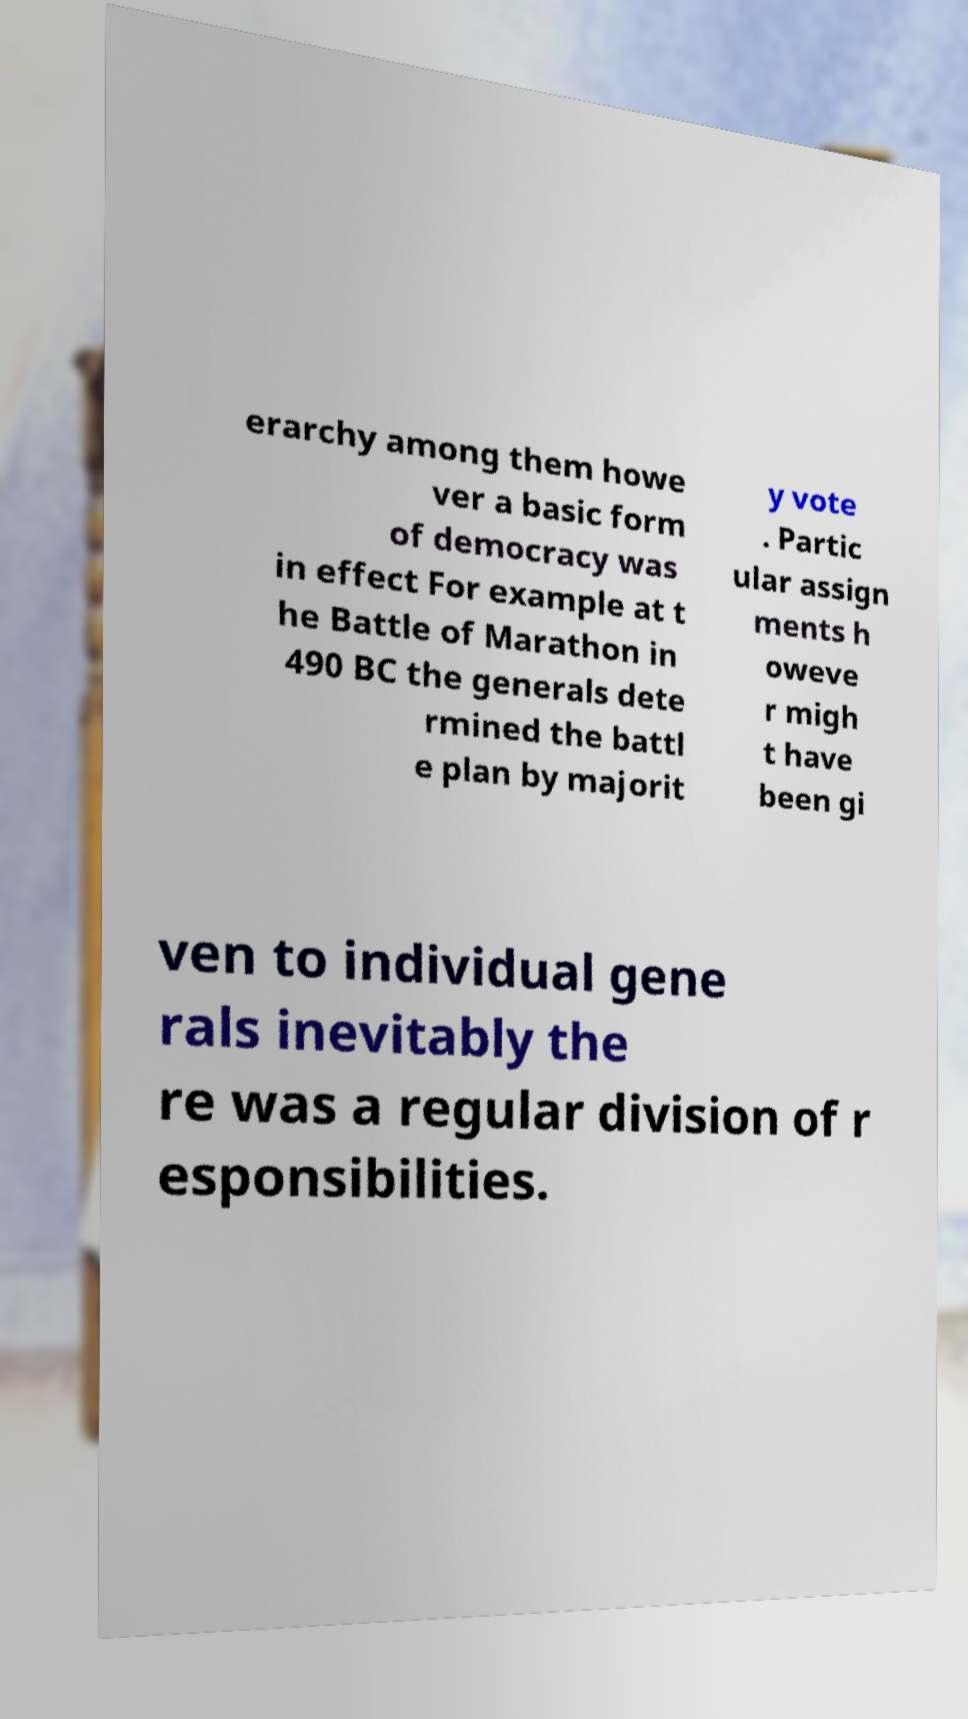For documentation purposes, I need the text within this image transcribed. Could you provide that? erarchy among them howe ver a basic form of democracy was in effect For example at t he Battle of Marathon in 490 BC the generals dete rmined the battl e plan by majorit y vote . Partic ular assign ments h oweve r migh t have been gi ven to individual gene rals inevitably the re was a regular division of r esponsibilities. 